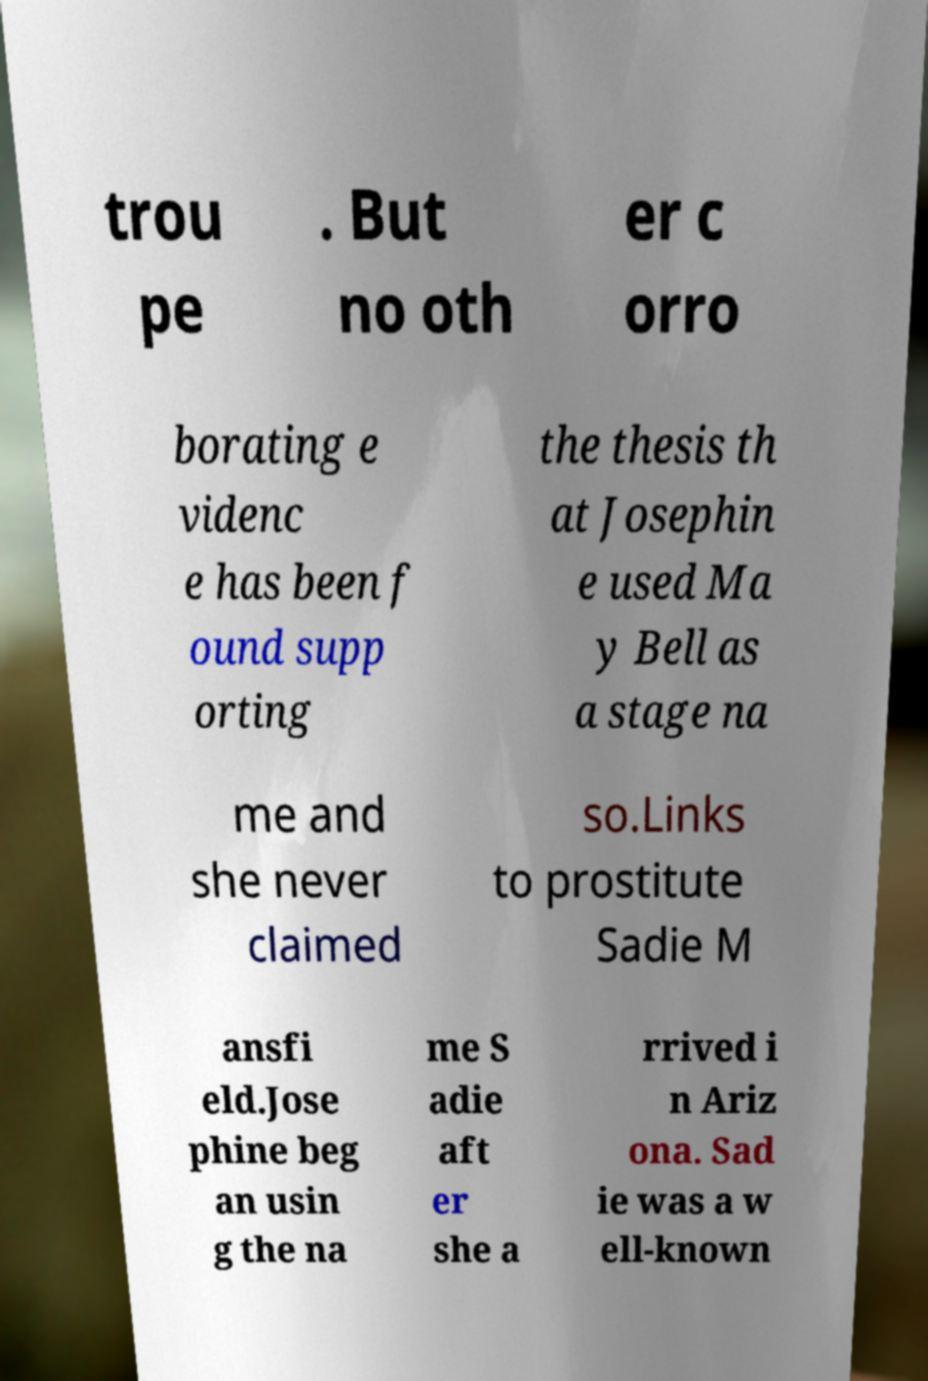For documentation purposes, I need the text within this image transcribed. Could you provide that? trou pe . But no oth er c orro borating e videnc e has been f ound supp orting the thesis th at Josephin e used Ma y Bell as a stage na me and she never claimed so.Links to prostitute Sadie M ansfi eld.Jose phine beg an usin g the na me S adie aft er she a rrived i n Ariz ona. Sad ie was a w ell-known 